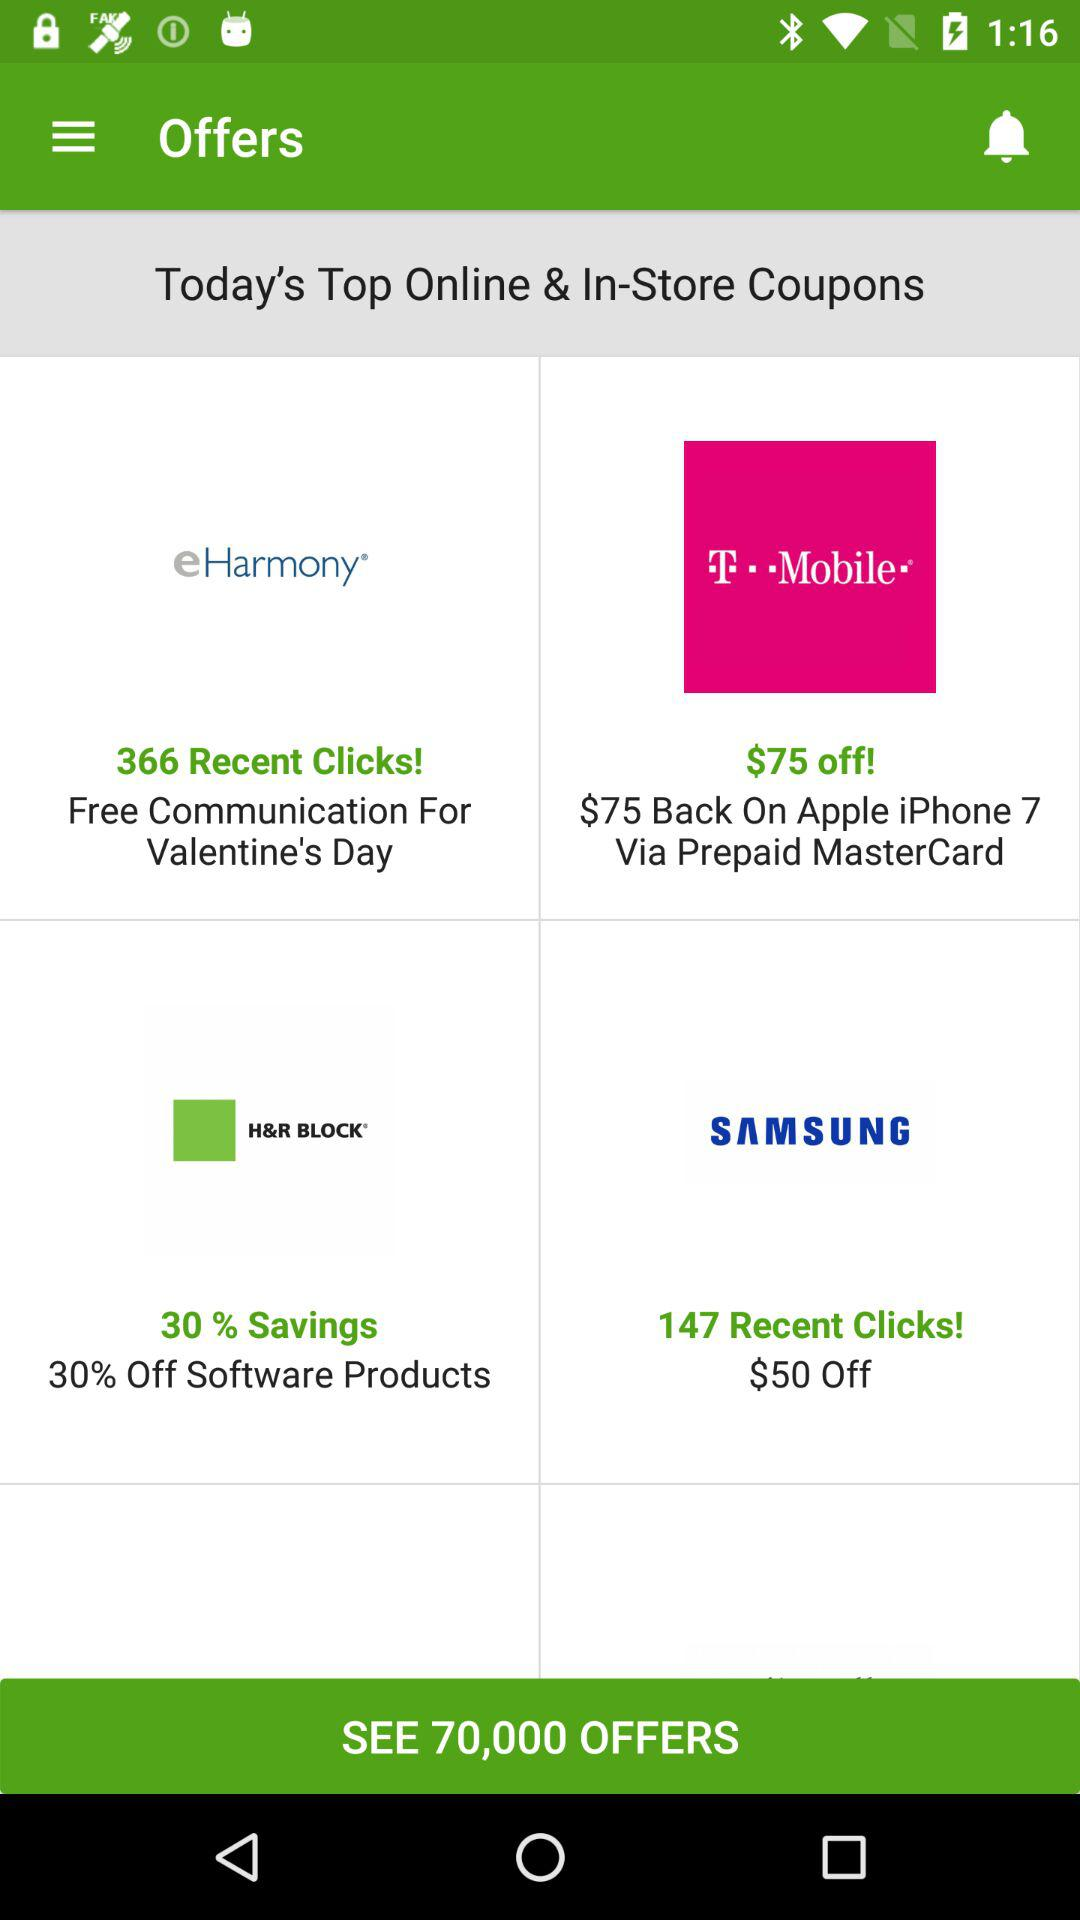How many coupons does "SAMSUNG" have?
When the provided information is insufficient, respond with <no answer>. <no answer> 